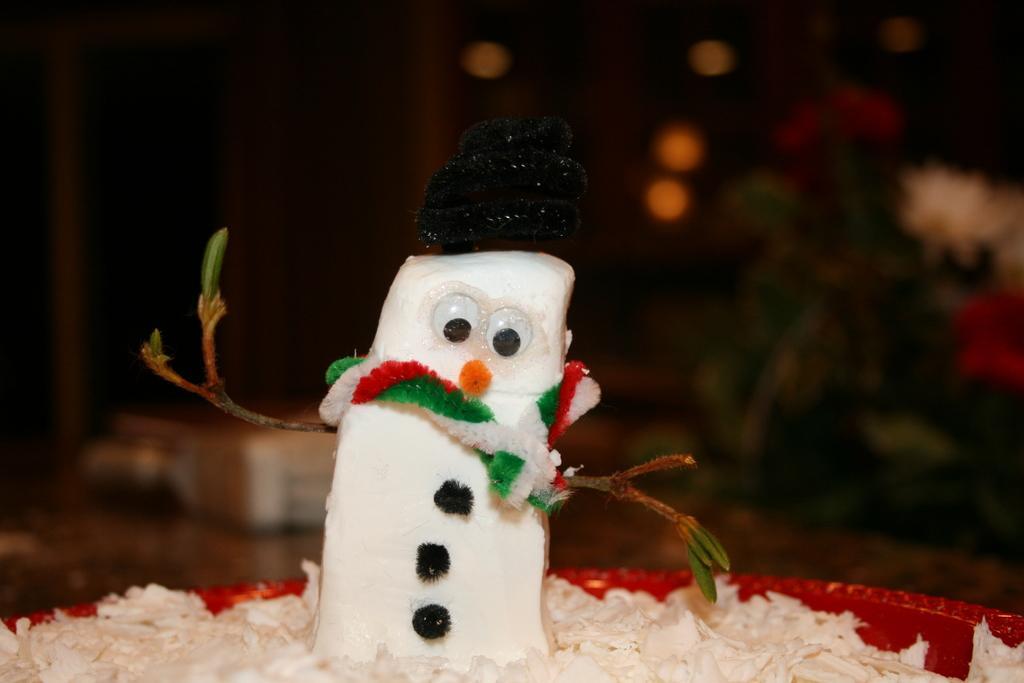How would you summarize this image in a sentence or two? In the image we can see a toy which looks like a snowman and the background is blurred. 